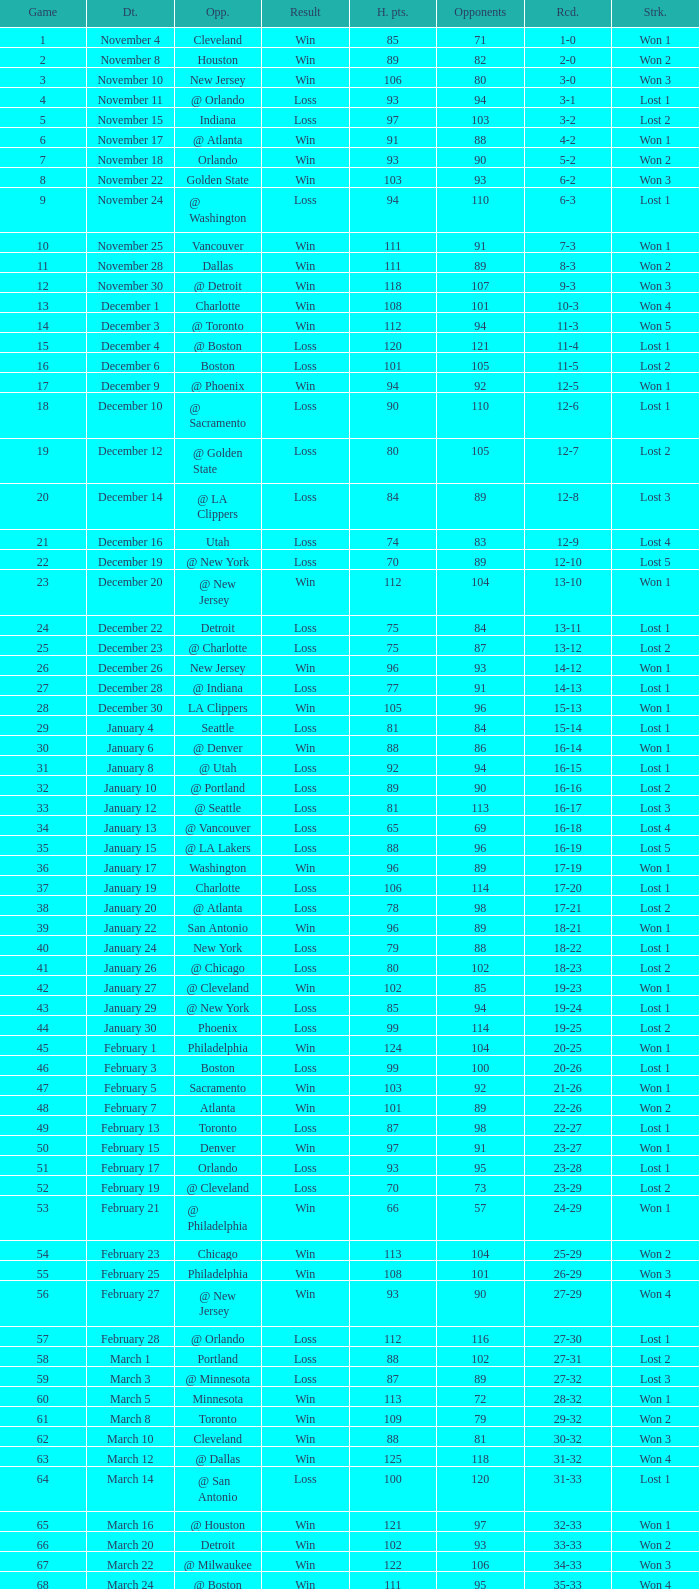What is the average Heat Points, when Result is "Loss", when Game is greater than 72, and when Date is "April 21"? 92.0. Would you be able to parse every entry in this table? {'header': ['Game', 'Dt.', 'Opp.', 'Result', 'H. pts.', 'Opponents', 'Rcd.', 'Strk.'], 'rows': [['1', 'November 4', 'Cleveland', 'Win', '85', '71', '1-0', 'Won 1'], ['2', 'November 8', 'Houston', 'Win', '89', '82', '2-0', 'Won 2'], ['3', 'November 10', 'New Jersey', 'Win', '106', '80', '3-0', 'Won 3'], ['4', 'November 11', '@ Orlando', 'Loss', '93', '94', '3-1', 'Lost 1'], ['5', 'November 15', 'Indiana', 'Loss', '97', '103', '3-2', 'Lost 2'], ['6', 'November 17', '@ Atlanta', 'Win', '91', '88', '4-2', 'Won 1'], ['7', 'November 18', 'Orlando', 'Win', '93', '90', '5-2', 'Won 2'], ['8', 'November 22', 'Golden State', 'Win', '103', '93', '6-2', 'Won 3'], ['9', 'November 24', '@ Washington', 'Loss', '94', '110', '6-3', 'Lost 1'], ['10', 'November 25', 'Vancouver', 'Win', '111', '91', '7-3', 'Won 1'], ['11', 'November 28', 'Dallas', 'Win', '111', '89', '8-3', 'Won 2'], ['12', 'November 30', '@ Detroit', 'Win', '118', '107', '9-3', 'Won 3'], ['13', 'December 1', 'Charlotte', 'Win', '108', '101', '10-3', 'Won 4'], ['14', 'December 3', '@ Toronto', 'Win', '112', '94', '11-3', 'Won 5'], ['15', 'December 4', '@ Boston', 'Loss', '120', '121', '11-4', 'Lost 1'], ['16', 'December 6', 'Boston', 'Loss', '101', '105', '11-5', 'Lost 2'], ['17', 'December 9', '@ Phoenix', 'Win', '94', '92', '12-5', 'Won 1'], ['18', 'December 10', '@ Sacramento', 'Loss', '90', '110', '12-6', 'Lost 1'], ['19', 'December 12', '@ Golden State', 'Loss', '80', '105', '12-7', 'Lost 2'], ['20', 'December 14', '@ LA Clippers', 'Loss', '84', '89', '12-8', 'Lost 3'], ['21', 'December 16', 'Utah', 'Loss', '74', '83', '12-9', 'Lost 4'], ['22', 'December 19', '@ New York', 'Loss', '70', '89', '12-10', 'Lost 5'], ['23', 'December 20', '@ New Jersey', 'Win', '112', '104', '13-10', 'Won 1'], ['24', 'December 22', 'Detroit', 'Loss', '75', '84', '13-11', 'Lost 1'], ['25', 'December 23', '@ Charlotte', 'Loss', '75', '87', '13-12', 'Lost 2'], ['26', 'December 26', 'New Jersey', 'Win', '96', '93', '14-12', 'Won 1'], ['27', 'December 28', '@ Indiana', 'Loss', '77', '91', '14-13', 'Lost 1'], ['28', 'December 30', 'LA Clippers', 'Win', '105', '96', '15-13', 'Won 1'], ['29', 'January 4', 'Seattle', 'Loss', '81', '84', '15-14', 'Lost 1'], ['30', 'January 6', '@ Denver', 'Win', '88', '86', '16-14', 'Won 1'], ['31', 'January 8', '@ Utah', 'Loss', '92', '94', '16-15', 'Lost 1'], ['32', 'January 10', '@ Portland', 'Loss', '89', '90', '16-16', 'Lost 2'], ['33', 'January 12', '@ Seattle', 'Loss', '81', '113', '16-17', 'Lost 3'], ['34', 'January 13', '@ Vancouver', 'Loss', '65', '69', '16-18', 'Lost 4'], ['35', 'January 15', '@ LA Lakers', 'Loss', '88', '96', '16-19', 'Lost 5'], ['36', 'January 17', 'Washington', 'Win', '96', '89', '17-19', 'Won 1'], ['37', 'January 19', 'Charlotte', 'Loss', '106', '114', '17-20', 'Lost 1'], ['38', 'January 20', '@ Atlanta', 'Loss', '78', '98', '17-21', 'Lost 2'], ['39', 'January 22', 'San Antonio', 'Win', '96', '89', '18-21', 'Won 1'], ['40', 'January 24', 'New York', 'Loss', '79', '88', '18-22', 'Lost 1'], ['41', 'January 26', '@ Chicago', 'Loss', '80', '102', '18-23', 'Lost 2'], ['42', 'January 27', '@ Cleveland', 'Win', '102', '85', '19-23', 'Won 1'], ['43', 'January 29', '@ New York', 'Loss', '85', '94', '19-24', 'Lost 1'], ['44', 'January 30', 'Phoenix', 'Loss', '99', '114', '19-25', 'Lost 2'], ['45', 'February 1', 'Philadelphia', 'Win', '124', '104', '20-25', 'Won 1'], ['46', 'February 3', 'Boston', 'Loss', '99', '100', '20-26', 'Lost 1'], ['47', 'February 5', 'Sacramento', 'Win', '103', '92', '21-26', 'Won 1'], ['48', 'February 7', 'Atlanta', 'Win', '101', '89', '22-26', 'Won 2'], ['49', 'February 13', 'Toronto', 'Loss', '87', '98', '22-27', 'Lost 1'], ['50', 'February 15', 'Denver', 'Win', '97', '91', '23-27', 'Won 1'], ['51', 'February 17', 'Orlando', 'Loss', '93', '95', '23-28', 'Lost 1'], ['52', 'February 19', '@ Cleveland', 'Loss', '70', '73', '23-29', 'Lost 2'], ['53', 'February 21', '@ Philadelphia', 'Win', '66', '57', '24-29', 'Won 1'], ['54', 'February 23', 'Chicago', 'Win', '113', '104', '25-29', 'Won 2'], ['55', 'February 25', 'Philadelphia', 'Win', '108', '101', '26-29', 'Won 3'], ['56', 'February 27', '@ New Jersey', 'Win', '93', '90', '27-29', 'Won 4'], ['57', 'February 28', '@ Orlando', 'Loss', '112', '116', '27-30', 'Lost 1'], ['58', 'March 1', 'Portland', 'Loss', '88', '102', '27-31', 'Lost 2'], ['59', 'March 3', '@ Minnesota', 'Loss', '87', '89', '27-32', 'Lost 3'], ['60', 'March 5', 'Minnesota', 'Win', '113', '72', '28-32', 'Won 1'], ['61', 'March 8', 'Toronto', 'Win', '109', '79', '29-32', 'Won 2'], ['62', 'March 10', 'Cleveland', 'Win', '88', '81', '30-32', 'Won 3'], ['63', 'March 12', '@ Dallas', 'Win', '125', '118', '31-32', 'Won 4'], ['64', 'March 14', '@ San Antonio', 'Loss', '100', '120', '31-33', 'Lost 1'], ['65', 'March 16', '@ Houston', 'Win', '121', '97', '32-33', 'Won 1'], ['66', 'March 20', 'Detroit', 'Win', '102', '93', '33-33', 'Won 2'], ['67', 'March 22', '@ Milwaukee', 'Win', '122', '106', '34-33', 'Won 3'], ['68', 'March 24', '@ Boston', 'Win', '111', '95', '35-33', 'Won 4'], ['69', 'March 27', 'LA Lakers', 'Loss', '95', '106', '35-34', 'Lost 1'], ['70', 'March 29', 'Washington', 'Win', '112', '93', '36-34', 'Won 1'], ['71', 'March 30', '@ Detroit', 'Win', '95', '85', '37-34', 'Won 2'], ['72', 'April 2', 'Chicago', 'Loss', '92', '110', '37-35', 'Lost 1'], ['73', 'April 4', '@ Chicago', 'Loss', '92', '100', '37-36', 'Lost 2'], ['74', 'April 6', '@ Indiana', 'Loss', '95', '99', '37-37', 'Lost 3'], ['75', 'April 8', '@ Washington', 'Loss', '99', '111', '37-38', 'Lost 4'], ['76', 'April 10', '@ Charlotte', 'Win', '116', '95', '38-38', 'Won 1'], ['77', 'April 11', 'Milwaukee', 'Win', '115', '105', '39-38', 'Won 2'], ['78', 'April 13', 'New York', 'Win', '103', '95', '40-38', 'Won 3'], ['79', 'April 15', 'New Jersey', 'Win', '110', '90', '41-38', 'Won 4'], ['80', 'April 17', '@ Philadelphia', 'Loss', '86', '90', '41-39', 'Lost 1'], ['81', 'April 19', '@ Milwaukee', 'Win', '106', '100', '42-39', 'Won 1'], ['82', 'April 21', 'Atlanta', 'Loss', '92', '104', '42-40', 'Lost 1'], ['1', 'April 26 (First Round)', '@ Chicago', 'Loss', '85', '102', '0-1', 'Lost 1'], ['2', 'April 28 (First Round)', '@ Chicago', 'Loss', '75', '106', '0-2', 'Lost 2'], ['3', 'May 1 (First Round)', 'Chicago', 'Loss', '91', '112', '0-3', 'Lost 3']]} 